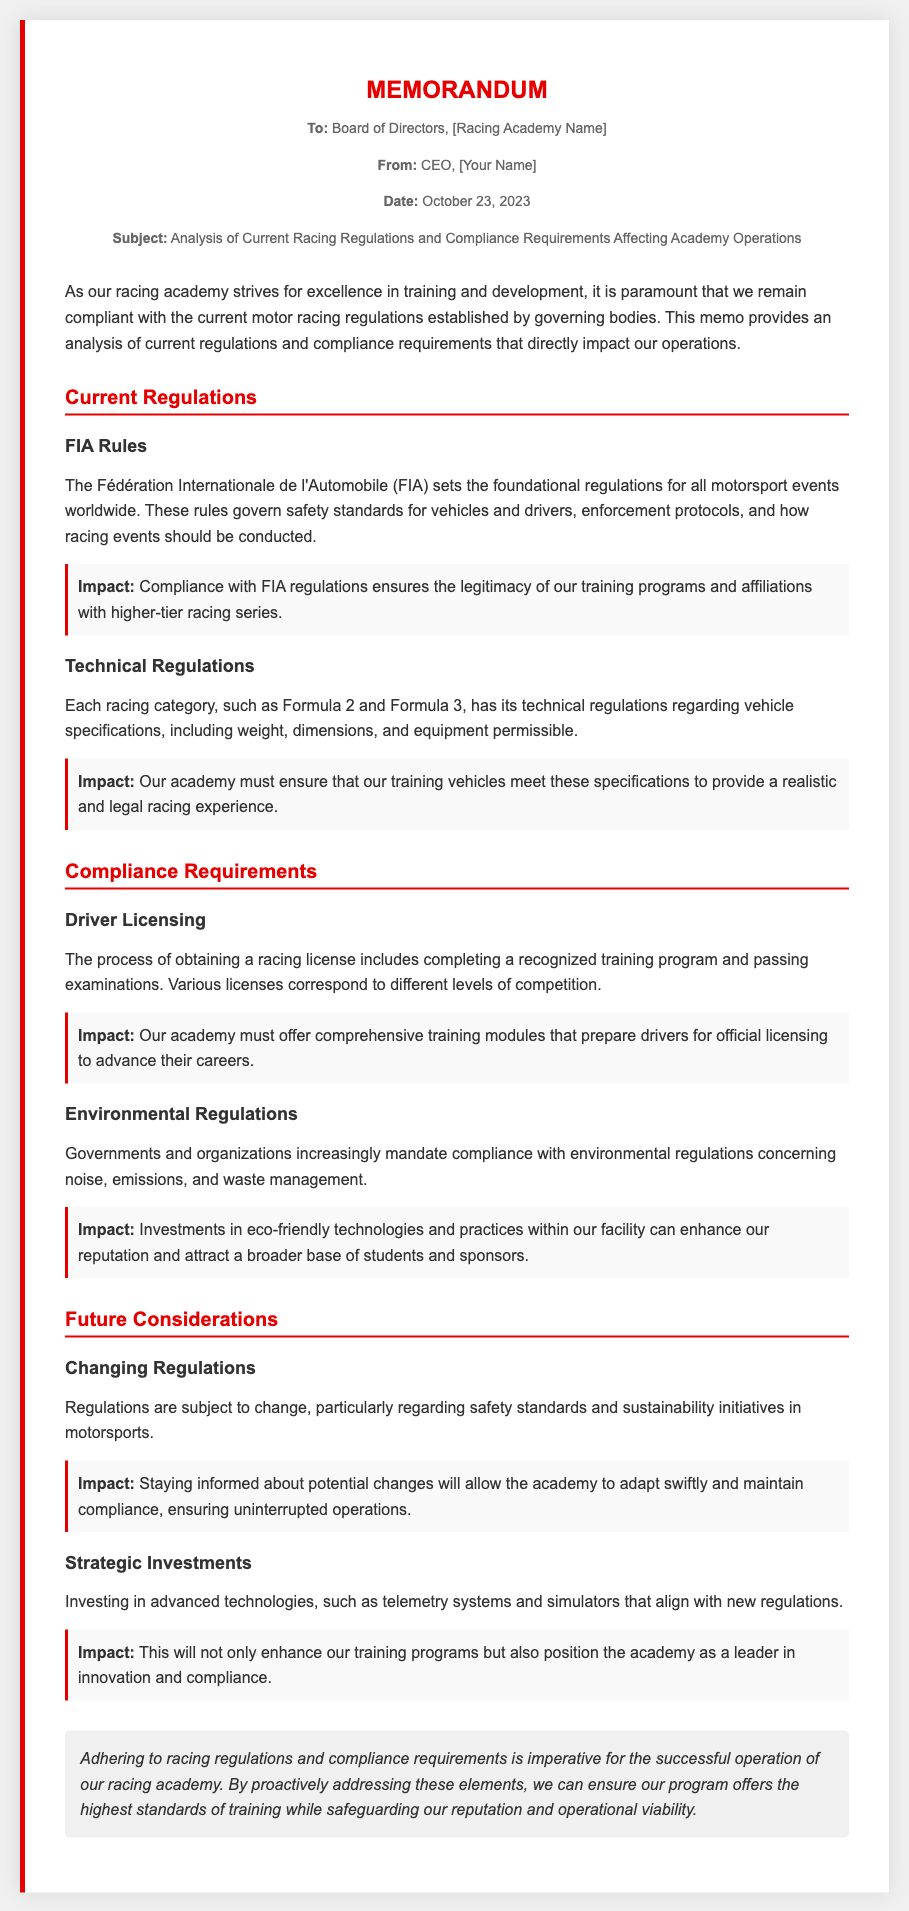What is the date of the memo? The date of the memo is stated in the meta section, indicating when it was written.
Answer: October 23, 2023 Who is the author of the memo? The author is identified directly below the recipient information in the meta section of the memo.
Answer: CEO, [Your Name] What body sets the foundational regulations for motorsport events? The document mentions a specific organization that governs the regulations for motorsport events worldwide.
Answer: FIA What impact does compliance with FIA regulations have? The document describes how compliance affects the legitimacy of training programs and affiliations.
Answer: Legitimacy of training programs What is required to obtain a racing license? The memo outlines a specific process that involves training and examinations for licensing.
Answer: Recognized training program and passing examinations What is an example of an environmental regulation mentioned? The memo discusses requirements regarding specific aspects of environmental impact related to motorsport activities.
Answer: Noise, emissions, and waste management What might changing regulations affect in the academy? The document discusses potential changes in regulations and how it can influence the operations of the academy.
Answer: Safety standards and sustainability initiatives What type of investments should the academy consider according to future considerations? The memo suggests investing in advancements that align with new regulations to enhance training.
Answer: Advanced technologies, telemetry systems and simulators What is the conclusion regarding adherence to racing regulations? The conclusion section summarizes the importance of compliance for successful operations within the academy.
Answer: Imperative for successful operation 